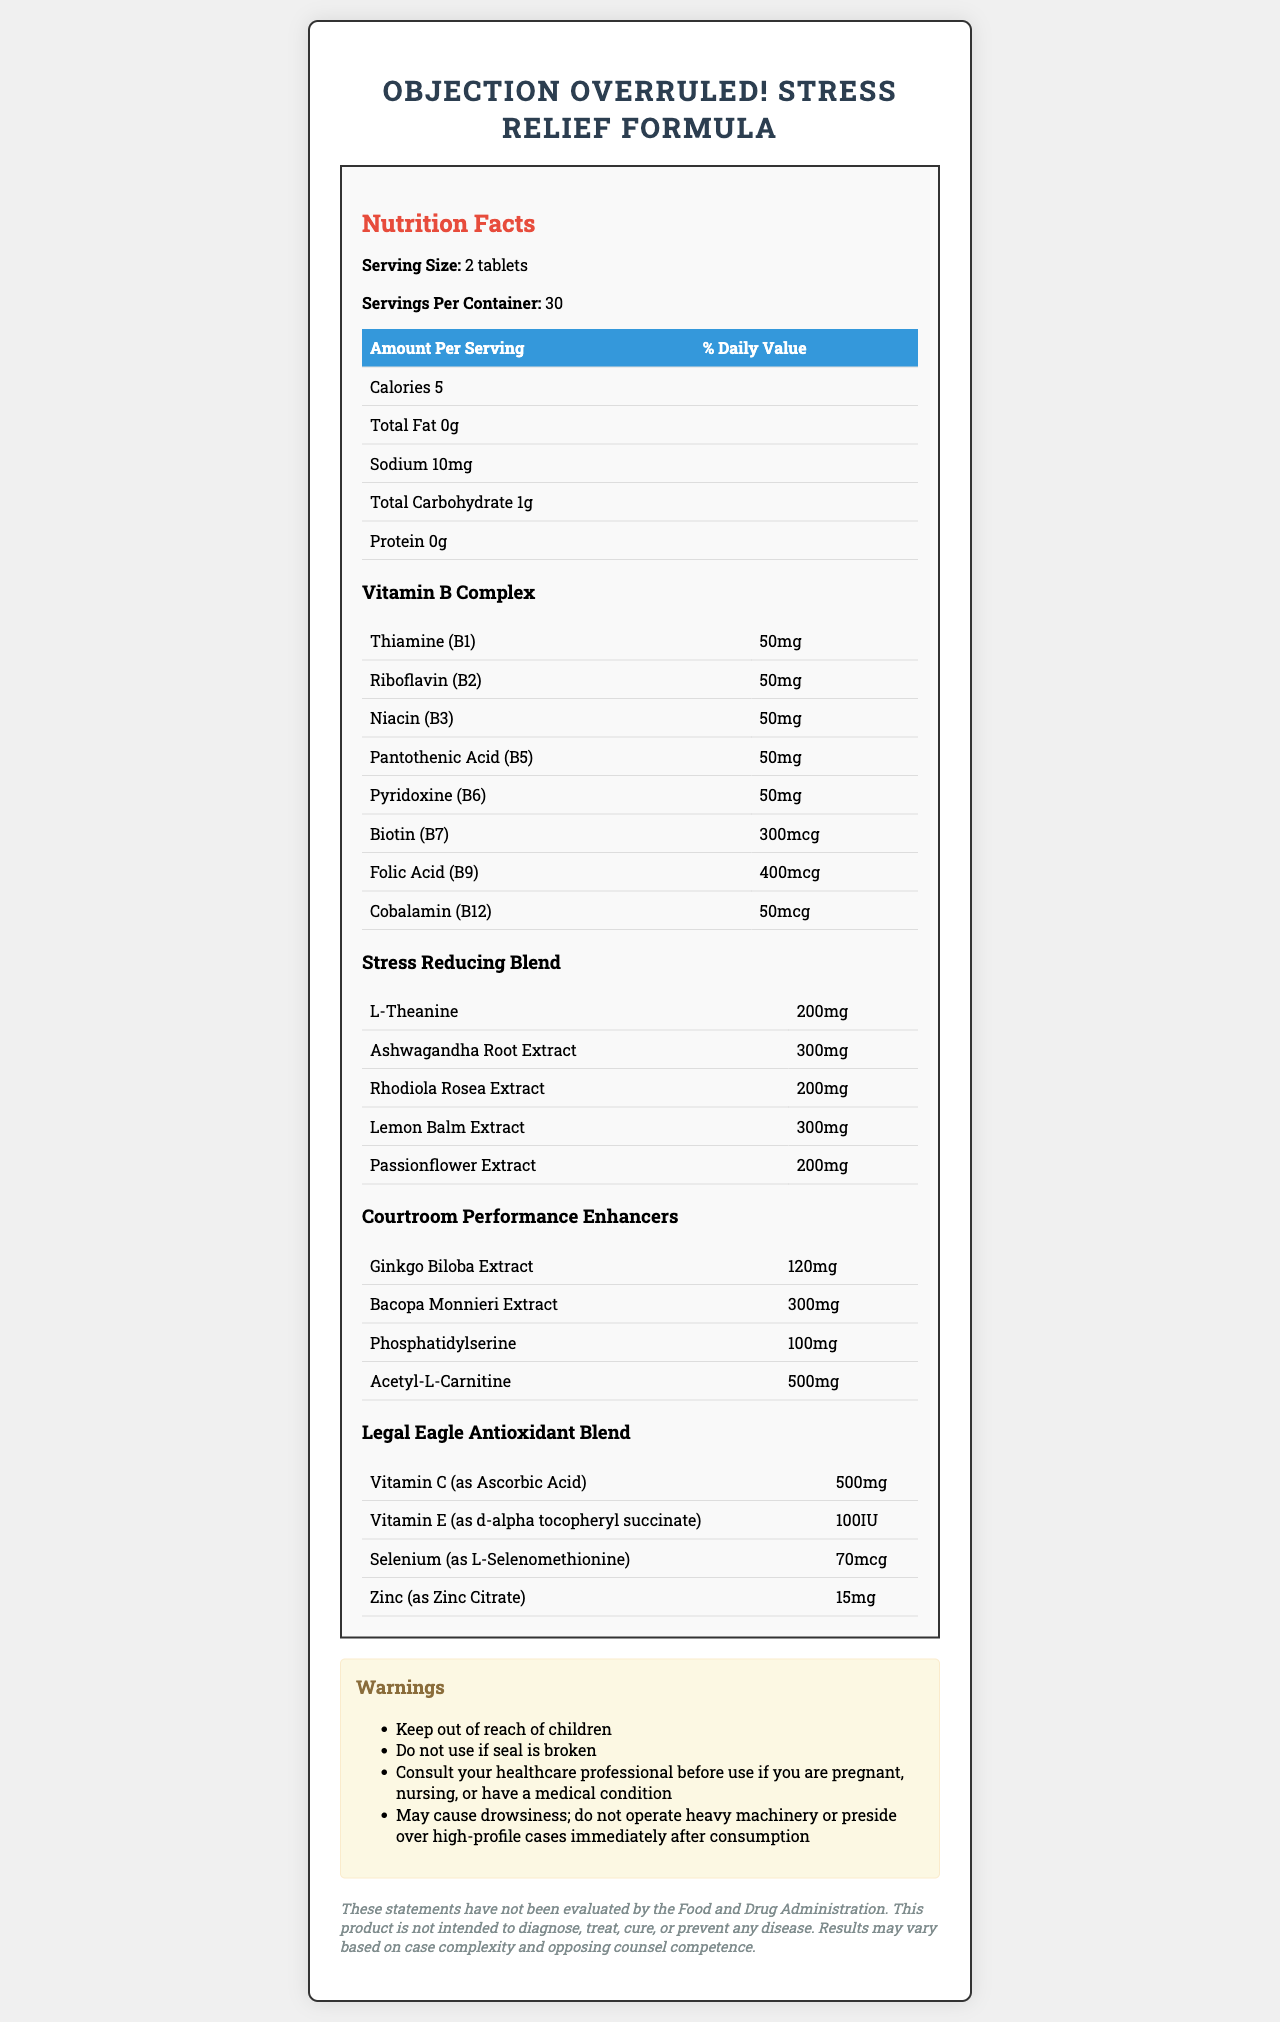what is the serving size? The document states the serving size as "2 tablets."
Answer: 2 tablets How many servings are there per container? The Nutrition Facts label lists "Servings Per Container: 30."
Answer: 30 what is the total amount of calories per serving? The document indicates there are 5 calories per serving.
Answer: 5 calories What is the sodium content per serving? The document lists sodium content as "10mg."
Answer: 10mg Name two ingredients in the Stress Reducing Blend. The document lists these ingredients under the Stress Reducing Blend.
Answer: L-Theanine, Ashwagandha Root Extract which vitamin has the highest dose in the Vitamin B Complex? The document lists all these vitamins at "50mg," which is the highest dose in the Vitamin B Complex.
Answer: Thiamine (B1), Riboflavin (B2), Niacin (B3), Pantothenic Acid (B5), Pyridoxine (B6) which of the following ingredients, if any, is found in the Legal Eagle Antioxidant Blend? A. L-Theanine B. Zinc C. Bacopa Monnieri Extract D. Ashwagandha Root Extract Zinc is listed in the Legal Eagle Antioxidant Blend.
Answer: B. Zinc how many calories are in a serving? A. 5 B. 10 C. 15 D. 20 The document states there are 5 calories per serving.
Answer: A. 5 Is this product suitable for someone who is allergic to soy? The allergen information states it is manufactured in a facility that also processes soy.
Answer: No Should you operate heavy machinery or preside over high-profile cases after taking this supplement? The warnings state "May cause drowsiness; do not operate heavy machinery or preside over high-profile cases immediately after consumption."
Answer: No Summarize the purpose and ingredients of this product. The document details the ingredients and nutritional information of the supplement, emphasizing its purpose of stress relief and courtroom performance enhancement, along with various warnings and a legal disclaimer.
Answer: "Objection Overruled! Stress Relief Formula" is a supplement aimed at reducing stress and enhancing courtroom performance with a variety of vitamins, stress-reducing herbs, performance enhancers, and antioxidants. It includes vitamins B1, B2, B3, B5, B6, B7, B9, and B12, a Stress Reducing Blend with ingredients like L-Theanine and Ashwagandha Root Extract, and other blends for performance and antioxidants. Are there any listed ingredients that are also antioxidants? These ingredients are specifically listed in the Legal Eagle Antioxidant Blend.
Answer: Vitamin C, Vitamin E, Selenium, Zinc which ingredient in the Courtroom Performance Enhancers has the highest dosage? The document lists Acetyl-L-Carnitine at "500mg," the highest dosage within the Courtroom Performance Enhancers.
Answer: Acetyl-L-Carnitine how should you take this supplement? The document provides this instruction under "Suggested Use."
Answer: "Take 2 tablets daily, preferably with meals or as directed by your healthcare professional." Are the benefits of this product evaluated by the Food and Drug Administration (FDA)? The legal disclaimer states that these statements have not been evaluated by the FDA.
Answer: No 